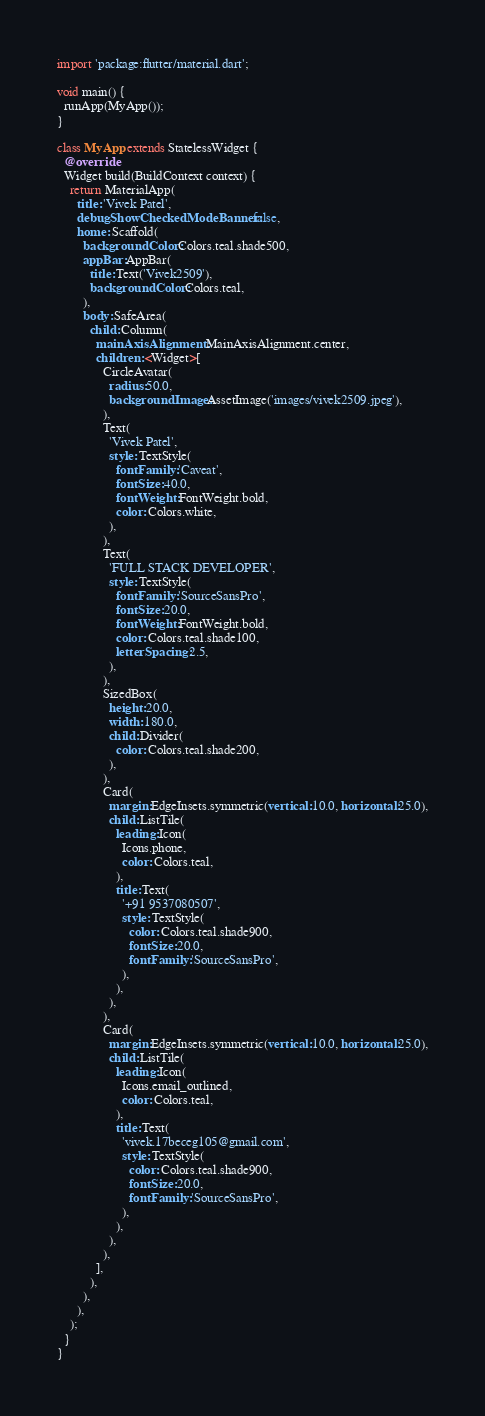<code> <loc_0><loc_0><loc_500><loc_500><_Dart_>import 'package:flutter/material.dart';

void main() {
  runApp(MyApp());
}

class MyApp extends StatelessWidget {
  @override
  Widget build(BuildContext context) {
    return MaterialApp(
      title: 'Vivek Patel',
      debugShowCheckedModeBanner: false,
      home: Scaffold(
        backgroundColor: Colors.teal.shade500,
        appBar: AppBar(
          title: Text('Vivek2509'),
          backgroundColor: Colors.teal,
        ),
        body: SafeArea(
          child: Column(
            mainAxisAlignment: MainAxisAlignment.center,
            children: <Widget>[
              CircleAvatar(
                radius: 50.0,
                backgroundImage: AssetImage('images/vivek2509.jpeg'),
              ),
              Text(
                'Vivek Patel',
                style: TextStyle(
                  fontFamily: 'Caveat',
                  fontSize: 40.0,
                  fontWeight: FontWeight.bold,
                  color: Colors.white,
                ),
              ),
              Text(
                'FULL STACK DEVELOPER',
                style: TextStyle(
                  fontFamily: 'SourceSansPro',
                  fontSize: 20.0,
                  fontWeight: FontWeight.bold,
                  color: Colors.teal.shade100,
                  letterSpacing: 2.5,
                ),
              ),
              SizedBox(
                height: 20.0,
                width: 180.0,
                child: Divider(
                  color: Colors.teal.shade200,
                ),
              ),
              Card(
                margin: EdgeInsets.symmetric(vertical: 10.0, horizontal: 25.0),
                child: ListTile(
                  leading: Icon(
                    Icons.phone,
                    color: Colors.teal,
                  ),
                  title: Text(
                    '+91 9537080507',
                    style: TextStyle(
                      color: Colors.teal.shade900,
                      fontSize: 20.0,
                      fontFamily: 'SourceSansPro',
                    ),
                  ),
                ),
              ),
              Card(
                margin: EdgeInsets.symmetric(vertical: 10.0, horizontal: 25.0),
                child: ListTile(
                  leading: Icon(
                    Icons.email_outlined,
                    color: Colors.teal,
                  ),
                  title: Text(
                    'vivek.17beceg105@gmail.com',
                    style: TextStyle(
                      color: Colors.teal.shade900,
                      fontSize: 20.0,
                      fontFamily: 'SourceSansPro',
                    ),
                  ),
                ),
              ),
            ],
          ),
        ),
      ),
    );
  }
}
</code> 